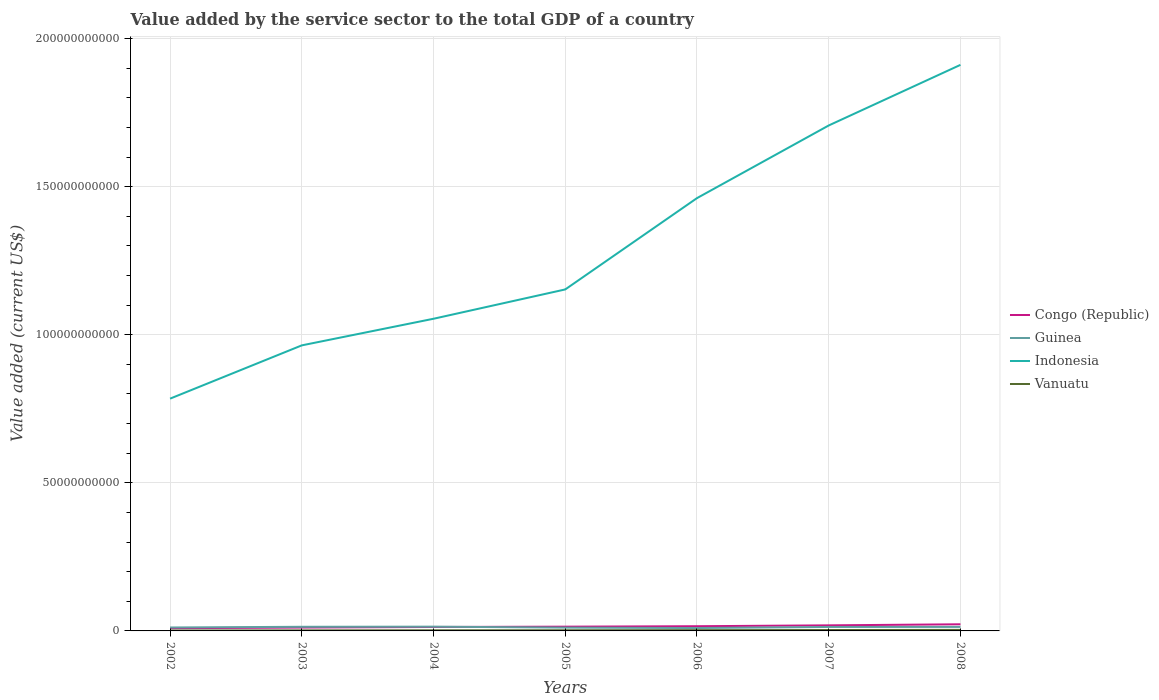Does the line corresponding to Congo (Republic) intersect with the line corresponding to Indonesia?
Provide a succinct answer. No. Is the number of lines equal to the number of legend labels?
Make the answer very short. Yes. Across all years, what is the maximum value added by the service sector to the total GDP in Congo (Republic)?
Keep it short and to the point. 9.19e+08. What is the total value added by the service sector to the total GDP in Vanuatu in the graph?
Give a very brief answer. -1.93e+07. What is the difference between the highest and the second highest value added by the service sector to the total GDP in Guinea?
Provide a short and direct response. 4.61e+08. How many lines are there?
Your response must be concise. 4. How many legend labels are there?
Your response must be concise. 4. How are the legend labels stacked?
Make the answer very short. Vertical. What is the title of the graph?
Keep it short and to the point. Value added by the service sector to the total GDP of a country. What is the label or title of the Y-axis?
Offer a terse response. Value added (current US$). What is the Value added (current US$) in Congo (Republic) in 2002?
Provide a short and direct response. 9.19e+08. What is the Value added (current US$) of Guinea in 2002?
Give a very brief answer. 1.16e+09. What is the Value added (current US$) of Indonesia in 2002?
Offer a terse response. 7.84e+1. What is the Value added (current US$) in Vanuatu in 2002?
Offer a very short reply. 1.45e+08. What is the Value added (current US$) of Congo (Republic) in 2003?
Provide a succinct answer. 1.14e+09. What is the Value added (current US$) in Guinea in 2003?
Make the answer very short. 1.40e+09. What is the Value added (current US$) in Indonesia in 2003?
Your answer should be compact. 9.64e+1. What is the Value added (current US$) of Vanuatu in 2003?
Your response must be concise. 1.81e+08. What is the Value added (current US$) in Congo (Republic) in 2004?
Keep it short and to the point. 1.33e+09. What is the Value added (current US$) in Guinea in 2004?
Ensure brevity in your answer.  1.44e+09. What is the Value added (current US$) in Indonesia in 2004?
Ensure brevity in your answer.  1.05e+11. What is the Value added (current US$) in Vanuatu in 2004?
Ensure brevity in your answer.  2.09e+08. What is the Value added (current US$) of Congo (Republic) in 2005?
Keep it short and to the point. 1.43e+09. What is the Value added (current US$) in Guinea in 2005?
Give a very brief answer. 1.11e+09. What is the Value added (current US$) of Indonesia in 2005?
Offer a very short reply. 1.15e+11. What is the Value added (current US$) in Vanuatu in 2005?
Offer a terse response. 2.29e+08. What is the Value added (current US$) of Congo (Republic) in 2006?
Keep it short and to the point. 1.59e+09. What is the Value added (current US$) of Guinea in 2006?
Offer a very short reply. 9.78e+08. What is the Value added (current US$) in Indonesia in 2006?
Your response must be concise. 1.46e+11. What is the Value added (current US$) in Vanuatu in 2006?
Give a very brief answer. 2.60e+08. What is the Value added (current US$) of Congo (Republic) in 2007?
Give a very brief answer. 1.88e+09. What is the Value added (current US$) of Guinea in 2007?
Make the answer very short. 1.34e+09. What is the Value added (current US$) in Indonesia in 2007?
Ensure brevity in your answer.  1.71e+11. What is the Value added (current US$) of Vanuatu in 2007?
Ensure brevity in your answer.  3.08e+08. What is the Value added (current US$) of Congo (Republic) in 2008?
Offer a terse response. 2.24e+09. What is the Value added (current US$) of Guinea in 2008?
Your answer should be very brief. 1.35e+09. What is the Value added (current US$) in Indonesia in 2008?
Offer a very short reply. 1.91e+11. What is the Value added (current US$) in Vanuatu in 2008?
Ensure brevity in your answer.  3.49e+08. Across all years, what is the maximum Value added (current US$) in Congo (Republic)?
Offer a terse response. 2.24e+09. Across all years, what is the maximum Value added (current US$) in Guinea?
Provide a succinct answer. 1.44e+09. Across all years, what is the maximum Value added (current US$) in Indonesia?
Give a very brief answer. 1.91e+11. Across all years, what is the maximum Value added (current US$) in Vanuatu?
Make the answer very short. 3.49e+08. Across all years, what is the minimum Value added (current US$) of Congo (Republic)?
Give a very brief answer. 9.19e+08. Across all years, what is the minimum Value added (current US$) of Guinea?
Offer a very short reply. 9.78e+08. Across all years, what is the minimum Value added (current US$) of Indonesia?
Offer a terse response. 7.84e+1. Across all years, what is the minimum Value added (current US$) in Vanuatu?
Provide a succinct answer. 1.45e+08. What is the total Value added (current US$) of Congo (Republic) in the graph?
Offer a very short reply. 1.05e+1. What is the total Value added (current US$) in Guinea in the graph?
Make the answer very short. 8.78e+09. What is the total Value added (current US$) in Indonesia in the graph?
Provide a short and direct response. 9.03e+11. What is the total Value added (current US$) of Vanuatu in the graph?
Provide a succinct answer. 1.68e+09. What is the difference between the Value added (current US$) of Congo (Republic) in 2002 and that in 2003?
Your response must be concise. -2.19e+08. What is the difference between the Value added (current US$) of Guinea in 2002 and that in 2003?
Keep it short and to the point. -2.35e+08. What is the difference between the Value added (current US$) of Indonesia in 2002 and that in 2003?
Provide a short and direct response. -1.80e+1. What is the difference between the Value added (current US$) in Vanuatu in 2002 and that in 2003?
Your response must be concise. -3.66e+07. What is the difference between the Value added (current US$) in Congo (Republic) in 2002 and that in 2004?
Provide a succinct answer. -4.12e+08. What is the difference between the Value added (current US$) in Guinea in 2002 and that in 2004?
Keep it short and to the point. -2.76e+08. What is the difference between the Value added (current US$) in Indonesia in 2002 and that in 2004?
Provide a short and direct response. -2.70e+1. What is the difference between the Value added (current US$) in Vanuatu in 2002 and that in 2004?
Give a very brief answer. -6.46e+07. What is the difference between the Value added (current US$) in Congo (Republic) in 2002 and that in 2005?
Offer a terse response. -5.16e+08. What is the difference between the Value added (current US$) of Guinea in 2002 and that in 2005?
Provide a succinct answer. 4.98e+07. What is the difference between the Value added (current US$) in Indonesia in 2002 and that in 2005?
Ensure brevity in your answer.  -3.69e+1. What is the difference between the Value added (current US$) of Vanuatu in 2002 and that in 2005?
Provide a succinct answer. -8.39e+07. What is the difference between the Value added (current US$) in Congo (Republic) in 2002 and that in 2006?
Provide a short and direct response. -6.69e+08. What is the difference between the Value added (current US$) of Guinea in 2002 and that in 2006?
Offer a very short reply. 1.84e+08. What is the difference between the Value added (current US$) of Indonesia in 2002 and that in 2006?
Offer a very short reply. -6.77e+1. What is the difference between the Value added (current US$) of Vanuatu in 2002 and that in 2006?
Provide a short and direct response. -1.15e+08. What is the difference between the Value added (current US$) of Congo (Republic) in 2002 and that in 2007?
Ensure brevity in your answer.  -9.64e+08. What is the difference between the Value added (current US$) of Guinea in 2002 and that in 2007?
Your response must be concise. -1.77e+08. What is the difference between the Value added (current US$) of Indonesia in 2002 and that in 2007?
Keep it short and to the point. -9.22e+1. What is the difference between the Value added (current US$) of Vanuatu in 2002 and that in 2007?
Provide a succinct answer. -1.63e+08. What is the difference between the Value added (current US$) in Congo (Republic) in 2002 and that in 2008?
Keep it short and to the point. -1.32e+09. What is the difference between the Value added (current US$) in Guinea in 2002 and that in 2008?
Give a very brief answer. -1.88e+08. What is the difference between the Value added (current US$) of Indonesia in 2002 and that in 2008?
Your answer should be compact. -1.13e+11. What is the difference between the Value added (current US$) in Vanuatu in 2002 and that in 2008?
Your answer should be very brief. -2.04e+08. What is the difference between the Value added (current US$) in Congo (Republic) in 2003 and that in 2004?
Ensure brevity in your answer.  -1.93e+08. What is the difference between the Value added (current US$) in Guinea in 2003 and that in 2004?
Make the answer very short. -4.10e+07. What is the difference between the Value added (current US$) of Indonesia in 2003 and that in 2004?
Provide a succinct answer. -8.99e+09. What is the difference between the Value added (current US$) of Vanuatu in 2003 and that in 2004?
Give a very brief answer. -2.80e+07. What is the difference between the Value added (current US$) in Congo (Republic) in 2003 and that in 2005?
Ensure brevity in your answer.  -2.97e+08. What is the difference between the Value added (current US$) of Guinea in 2003 and that in 2005?
Offer a very short reply. 2.85e+08. What is the difference between the Value added (current US$) of Indonesia in 2003 and that in 2005?
Your response must be concise. -1.89e+1. What is the difference between the Value added (current US$) in Vanuatu in 2003 and that in 2005?
Ensure brevity in your answer.  -4.73e+07. What is the difference between the Value added (current US$) of Congo (Republic) in 2003 and that in 2006?
Provide a succinct answer. -4.50e+08. What is the difference between the Value added (current US$) of Guinea in 2003 and that in 2006?
Offer a terse response. 4.20e+08. What is the difference between the Value added (current US$) of Indonesia in 2003 and that in 2006?
Your answer should be very brief. -4.97e+1. What is the difference between the Value added (current US$) in Vanuatu in 2003 and that in 2006?
Your response must be concise. -7.84e+07. What is the difference between the Value added (current US$) in Congo (Republic) in 2003 and that in 2007?
Keep it short and to the point. -7.45e+08. What is the difference between the Value added (current US$) in Guinea in 2003 and that in 2007?
Provide a short and direct response. 5.83e+07. What is the difference between the Value added (current US$) of Indonesia in 2003 and that in 2007?
Provide a short and direct response. -7.42e+1. What is the difference between the Value added (current US$) in Vanuatu in 2003 and that in 2007?
Your answer should be very brief. -1.26e+08. What is the difference between the Value added (current US$) in Congo (Republic) in 2003 and that in 2008?
Offer a very short reply. -1.10e+09. What is the difference between the Value added (current US$) of Guinea in 2003 and that in 2008?
Offer a terse response. 4.74e+07. What is the difference between the Value added (current US$) in Indonesia in 2003 and that in 2008?
Ensure brevity in your answer.  -9.47e+1. What is the difference between the Value added (current US$) in Vanuatu in 2003 and that in 2008?
Give a very brief answer. -1.67e+08. What is the difference between the Value added (current US$) in Congo (Republic) in 2004 and that in 2005?
Offer a very short reply. -1.04e+08. What is the difference between the Value added (current US$) of Guinea in 2004 and that in 2005?
Offer a terse response. 3.26e+08. What is the difference between the Value added (current US$) in Indonesia in 2004 and that in 2005?
Provide a short and direct response. -9.90e+09. What is the difference between the Value added (current US$) of Vanuatu in 2004 and that in 2005?
Ensure brevity in your answer.  -1.93e+07. What is the difference between the Value added (current US$) of Congo (Republic) in 2004 and that in 2006?
Make the answer very short. -2.57e+08. What is the difference between the Value added (current US$) of Guinea in 2004 and that in 2006?
Provide a succinct answer. 4.61e+08. What is the difference between the Value added (current US$) of Indonesia in 2004 and that in 2006?
Ensure brevity in your answer.  -4.07e+1. What is the difference between the Value added (current US$) in Vanuatu in 2004 and that in 2006?
Make the answer very short. -5.04e+07. What is the difference between the Value added (current US$) in Congo (Republic) in 2004 and that in 2007?
Make the answer very short. -5.52e+08. What is the difference between the Value added (current US$) in Guinea in 2004 and that in 2007?
Provide a succinct answer. 9.93e+07. What is the difference between the Value added (current US$) in Indonesia in 2004 and that in 2007?
Keep it short and to the point. -6.53e+1. What is the difference between the Value added (current US$) in Vanuatu in 2004 and that in 2007?
Offer a very short reply. -9.82e+07. What is the difference between the Value added (current US$) in Congo (Republic) in 2004 and that in 2008?
Keep it short and to the point. -9.12e+08. What is the difference between the Value added (current US$) of Guinea in 2004 and that in 2008?
Keep it short and to the point. 8.85e+07. What is the difference between the Value added (current US$) of Indonesia in 2004 and that in 2008?
Ensure brevity in your answer.  -8.57e+1. What is the difference between the Value added (current US$) of Vanuatu in 2004 and that in 2008?
Your response must be concise. -1.39e+08. What is the difference between the Value added (current US$) of Congo (Republic) in 2005 and that in 2006?
Give a very brief answer. -1.53e+08. What is the difference between the Value added (current US$) of Guinea in 2005 and that in 2006?
Offer a terse response. 1.35e+08. What is the difference between the Value added (current US$) of Indonesia in 2005 and that in 2006?
Your answer should be compact. -3.08e+1. What is the difference between the Value added (current US$) in Vanuatu in 2005 and that in 2006?
Offer a very short reply. -3.11e+07. What is the difference between the Value added (current US$) of Congo (Republic) in 2005 and that in 2007?
Provide a succinct answer. -4.48e+08. What is the difference between the Value added (current US$) of Guinea in 2005 and that in 2007?
Your response must be concise. -2.27e+08. What is the difference between the Value added (current US$) in Indonesia in 2005 and that in 2007?
Offer a terse response. -5.54e+1. What is the difference between the Value added (current US$) in Vanuatu in 2005 and that in 2007?
Offer a terse response. -7.89e+07. What is the difference between the Value added (current US$) of Congo (Republic) in 2005 and that in 2008?
Provide a succinct answer. -8.07e+08. What is the difference between the Value added (current US$) in Guinea in 2005 and that in 2008?
Provide a succinct answer. -2.38e+08. What is the difference between the Value added (current US$) of Indonesia in 2005 and that in 2008?
Give a very brief answer. -7.58e+1. What is the difference between the Value added (current US$) in Vanuatu in 2005 and that in 2008?
Offer a very short reply. -1.20e+08. What is the difference between the Value added (current US$) in Congo (Republic) in 2006 and that in 2007?
Keep it short and to the point. -2.95e+08. What is the difference between the Value added (current US$) of Guinea in 2006 and that in 2007?
Provide a succinct answer. -3.61e+08. What is the difference between the Value added (current US$) in Indonesia in 2006 and that in 2007?
Your answer should be compact. -2.45e+1. What is the difference between the Value added (current US$) of Vanuatu in 2006 and that in 2007?
Offer a very short reply. -4.78e+07. What is the difference between the Value added (current US$) of Congo (Republic) in 2006 and that in 2008?
Your response must be concise. -6.55e+08. What is the difference between the Value added (current US$) of Guinea in 2006 and that in 2008?
Your response must be concise. -3.72e+08. What is the difference between the Value added (current US$) in Indonesia in 2006 and that in 2008?
Your answer should be compact. -4.50e+1. What is the difference between the Value added (current US$) of Vanuatu in 2006 and that in 2008?
Your answer should be very brief. -8.88e+07. What is the difference between the Value added (current US$) in Congo (Republic) in 2007 and that in 2008?
Your answer should be compact. -3.59e+08. What is the difference between the Value added (current US$) in Guinea in 2007 and that in 2008?
Make the answer very short. -1.09e+07. What is the difference between the Value added (current US$) in Indonesia in 2007 and that in 2008?
Provide a short and direct response. -2.05e+1. What is the difference between the Value added (current US$) in Vanuatu in 2007 and that in 2008?
Your response must be concise. -4.10e+07. What is the difference between the Value added (current US$) of Congo (Republic) in 2002 and the Value added (current US$) of Guinea in 2003?
Give a very brief answer. -4.79e+08. What is the difference between the Value added (current US$) in Congo (Republic) in 2002 and the Value added (current US$) in Indonesia in 2003?
Ensure brevity in your answer.  -9.55e+1. What is the difference between the Value added (current US$) in Congo (Republic) in 2002 and the Value added (current US$) in Vanuatu in 2003?
Make the answer very short. 7.37e+08. What is the difference between the Value added (current US$) in Guinea in 2002 and the Value added (current US$) in Indonesia in 2003?
Offer a terse response. -9.52e+1. What is the difference between the Value added (current US$) in Guinea in 2002 and the Value added (current US$) in Vanuatu in 2003?
Provide a short and direct response. 9.81e+08. What is the difference between the Value added (current US$) in Indonesia in 2002 and the Value added (current US$) in Vanuatu in 2003?
Give a very brief answer. 7.82e+1. What is the difference between the Value added (current US$) in Congo (Republic) in 2002 and the Value added (current US$) in Guinea in 2004?
Offer a terse response. -5.20e+08. What is the difference between the Value added (current US$) of Congo (Republic) in 2002 and the Value added (current US$) of Indonesia in 2004?
Offer a very short reply. -1.04e+11. What is the difference between the Value added (current US$) in Congo (Republic) in 2002 and the Value added (current US$) in Vanuatu in 2004?
Your answer should be compact. 7.09e+08. What is the difference between the Value added (current US$) in Guinea in 2002 and the Value added (current US$) in Indonesia in 2004?
Give a very brief answer. -1.04e+11. What is the difference between the Value added (current US$) of Guinea in 2002 and the Value added (current US$) of Vanuatu in 2004?
Offer a very short reply. 9.53e+08. What is the difference between the Value added (current US$) in Indonesia in 2002 and the Value added (current US$) in Vanuatu in 2004?
Your answer should be compact. 7.82e+1. What is the difference between the Value added (current US$) in Congo (Republic) in 2002 and the Value added (current US$) in Guinea in 2005?
Give a very brief answer. -1.94e+08. What is the difference between the Value added (current US$) in Congo (Republic) in 2002 and the Value added (current US$) in Indonesia in 2005?
Give a very brief answer. -1.14e+11. What is the difference between the Value added (current US$) in Congo (Republic) in 2002 and the Value added (current US$) in Vanuatu in 2005?
Provide a short and direct response. 6.90e+08. What is the difference between the Value added (current US$) in Guinea in 2002 and the Value added (current US$) in Indonesia in 2005?
Make the answer very short. -1.14e+11. What is the difference between the Value added (current US$) of Guinea in 2002 and the Value added (current US$) of Vanuatu in 2005?
Keep it short and to the point. 9.34e+08. What is the difference between the Value added (current US$) in Indonesia in 2002 and the Value added (current US$) in Vanuatu in 2005?
Keep it short and to the point. 7.82e+1. What is the difference between the Value added (current US$) in Congo (Republic) in 2002 and the Value added (current US$) in Guinea in 2006?
Your answer should be compact. -5.96e+07. What is the difference between the Value added (current US$) of Congo (Republic) in 2002 and the Value added (current US$) of Indonesia in 2006?
Your answer should be very brief. -1.45e+11. What is the difference between the Value added (current US$) of Congo (Republic) in 2002 and the Value added (current US$) of Vanuatu in 2006?
Provide a short and direct response. 6.59e+08. What is the difference between the Value added (current US$) of Guinea in 2002 and the Value added (current US$) of Indonesia in 2006?
Provide a short and direct response. -1.45e+11. What is the difference between the Value added (current US$) of Guinea in 2002 and the Value added (current US$) of Vanuatu in 2006?
Offer a terse response. 9.03e+08. What is the difference between the Value added (current US$) in Indonesia in 2002 and the Value added (current US$) in Vanuatu in 2006?
Your answer should be compact. 7.82e+1. What is the difference between the Value added (current US$) in Congo (Republic) in 2002 and the Value added (current US$) in Guinea in 2007?
Make the answer very short. -4.21e+08. What is the difference between the Value added (current US$) in Congo (Republic) in 2002 and the Value added (current US$) in Indonesia in 2007?
Ensure brevity in your answer.  -1.70e+11. What is the difference between the Value added (current US$) in Congo (Republic) in 2002 and the Value added (current US$) in Vanuatu in 2007?
Your answer should be compact. 6.11e+08. What is the difference between the Value added (current US$) of Guinea in 2002 and the Value added (current US$) of Indonesia in 2007?
Make the answer very short. -1.69e+11. What is the difference between the Value added (current US$) in Guinea in 2002 and the Value added (current US$) in Vanuatu in 2007?
Your answer should be very brief. 8.55e+08. What is the difference between the Value added (current US$) of Indonesia in 2002 and the Value added (current US$) of Vanuatu in 2007?
Your answer should be compact. 7.81e+1. What is the difference between the Value added (current US$) of Congo (Republic) in 2002 and the Value added (current US$) of Guinea in 2008?
Your answer should be compact. -4.32e+08. What is the difference between the Value added (current US$) in Congo (Republic) in 2002 and the Value added (current US$) in Indonesia in 2008?
Provide a short and direct response. -1.90e+11. What is the difference between the Value added (current US$) of Congo (Republic) in 2002 and the Value added (current US$) of Vanuatu in 2008?
Give a very brief answer. 5.70e+08. What is the difference between the Value added (current US$) in Guinea in 2002 and the Value added (current US$) in Indonesia in 2008?
Give a very brief answer. -1.90e+11. What is the difference between the Value added (current US$) of Guinea in 2002 and the Value added (current US$) of Vanuatu in 2008?
Offer a very short reply. 8.14e+08. What is the difference between the Value added (current US$) of Indonesia in 2002 and the Value added (current US$) of Vanuatu in 2008?
Provide a short and direct response. 7.81e+1. What is the difference between the Value added (current US$) of Congo (Republic) in 2003 and the Value added (current US$) of Guinea in 2004?
Make the answer very short. -3.01e+08. What is the difference between the Value added (current US$) in Congo (Republic) in 2003 and the Value added (current US$) in Indonesia in 2004?
Your response must be concise. -1.04e+11. What is the difference between the Value added (current US$) in Congo (Republic) in 2003 and the Value added (current US$) in Vanuatu in 2004?
Offer a terse response. 9.29e+08. What is the difference between the Value added (current US$) of Guinea in 2003 and the Value added (current US$) of Indonesia in 2004?
Your answer should be compact. -1.04e+11. What is the difference between the Value added (current US$) in Guinea in 2003 and the Value added (current US$) in Vanuatu in 2004?
Make the answer very short. 1.19e+09. What is the difference between the Value added (current US$) in Indonesia in 2003 and the Value added (current US$) in Vanuatu in 2004?
Your answer should be very brief. 9.62e+1. What is the difference between the Value added (current US$) in Congo (Republic) in 2003 and the Value added (current US$) in Guinea in 2005?
Keep it short and to the point. 2.52e+07. What is the difference between the Value added (current US$) in Congo (Republic) in 2003 and the Value added (current US$) in Indonesia in 2005?
Your answer should be compact. -1.14e+11. What is the difference between the Value added (current US$) of Congo (Republic) in 2003 and the Value added (current US$) of Vanuatu in 2005?
Offer a very short reply. 9.09e+08. What is the difference between the Value added (current US$) in Guinea in 2003 and the Value added (current US$) in Indonesia in 2005?
Your answer should be compact. -1.14e+11. What is the difference between the Value added (current US$) of Guinea in 2003 and the Value added (current US$) of Vanuatu in 2005?
Offer a terse response. 1.17e+09. What is the difference between the Value added (current US$) in Indonesia in 2003 and the Value added (current US$) in Vanuatu in 2005?
Give a very brief answer. 9.62e+1. What is the difference between the Value added (current US$) in Congo (Republic) in 2003 and the Value added (current US$) in Guinea in 2006?
Provide a short and direct response. 1.60e+08. What is the difference between the Value added (current US$) of Congo (Republic) in 2003 and the Value added (current US$) of Indonesia in 2006?
Your answer should be compact. -1.45e+11. What is the difference between the Value added (current US$) of Congo (Republic) in 2003 and the Value added (current US$) of Vanuatu in 2006?
Provide a short and direct response. 8.78e+08. What is the difference between the Value added (current US$) of Guinea in 2003 and the Value added (current US$) of Indonesia in 2006?
Your answer should be very brief. -1.45e+11. What is the difference between the Value added (current US$) in Guinea in 2003 and the Value added (current US$) in Vanuatu in 2006?
Your answer should be compact. 1.14e+09. What is the difference between the Value added (current US$) in Indonesia in 2003 and the Value added (current US$) in Vanuatu in 2006?
Provide a succinct answer. 9.61e+1. What is the difference between the Value added (current US$) of Congo (Republic) in 2003 and the Value added (current US$) of Guinea in 2007?
Your answer should be very brief. -2.02e+08. What is the difference between the Value added (current US$) in Congo (Republic) in 2003 and the Value added (current US$) in Indonesia in 2007?
Your answer should be very brief. -1.70e+11. What is the difference between the Value added (current US$) of Congo (Republic) in 2003 and the Value added (current US$) of Vanuatu in 2007?
Give a very brief answer. 8.30e+08. What is the difference between the Value added (current US$) of Guinea in 2003 and the Value added (current US$) of Indonesia in 2007?
Make the answer very short. -1.69e+11. What is the difference between the Value added (current US$) of Guinea in 2003 and the Value added (current US$) of Vanuatu in 2007?
Offer a very short reply. 1.09e+09. What is the difference between the Value added (current US$) of Indonesia in 2003 and the Value added (current US$) of Vanuatu in 2007?
Give a very brief answer. 9.61e+1. What is the difference between the Value added (current US$) in Congo (Republic) in 2003 and the Value added (current US$) in Guinea in 2008?
Make the answer very short. -2.12e+08. What is the difference between the Value added (current US$) in Congo (Republic) in 2003 and the Value added (current US$) in Indonesia in 2008?
Offer a very short reply. -1.90e+11. What is the difference between the Value added (current US$) in Congo (Republic) in 2003 and the Value added (current US$) in Vanuatu in 2008?
Give a very brief answer. 7.89e+08. What is the difference between the Value added (current US$) in Guinea in 2003 and the Value added (current US$) in Indonesia in 2008?
Make the answer very short. -1.90e+11. What is the difference between the Value added (current US$) of Guinea in 2003 and the Value added (current US$) of Vanuatu in 2008?
Keep it short and to the point. 1.05e+09. What is the difference between the Value added (current US$) in Indonesia in 2003 and the Value added (current US$) in Vanuatu in 2008?
Your answer should be very brief. 9.61e+1. What is the difference between the Value added (current US$) in Congo (Republic) in 2004 and the Value added (current US$) in Guinea in 2005?
Offer a terse response. 2.18e+08. What is the difference between the Value added (current US$) in Congo (Republic) in 2004 and the Value added (current US$) in Indonesia in 2005?
Your response must be concise. -1.14e+11. What is the difference between the Value added (current US$) in Congo (Republic) in 2004 and the Value added (current US$) in Vanuatu in 2005?
Offer a terse response. 1.10e+09. What is the difference between the Value added (current US$) in Guinea in 2004 and the Value added (current US$) in Indonesia in 2005?
Your response must be concise. -1.14e+11. What is the difference between the Value added (current US$) of Guinea in 2004 and the Value added (current US$) of Vanuatu in 2005?
Provide a succinct answer. 1.21e+09. What is the difference between the Value added (current US$) in Indonesia in 2004 and the Value added (current US$) in Vanuatu in 2005?
Your response must be concise. 1.05e+11. What is the difference between the Value added (current US$) of Congo (Republic) in 2004 and the Value added (current US$) of Guinea in 2006?
Offer a very short reply. 3.52e+08. What is the difference between the Value added (current US$) of Congo (Republic) in 2004 and the Value added (current US$) of Indonesia in 2006?
Offer a terse response. -1.45e+11. What is the difference between the Value added (current US$) in Congo (Republic) in 2004 and the Value added (current US$) in Vanuatu in 2006?
Your answer should be very brief. 1.07e+09. What is the difference between the Value added (current US$) of Guinea in 2004 and the Value added (current US$) of Indonesia in 2006?
Ensure brevity in your answer.  -1.45e+11. What is the difference between the Value added (current US$) in Guinea in 2004 and the Value added (current US$) in Vanuatu in 2006?
Provide a succinct answer. 1.18e+09. What is the difference between the Value added (current US$) of Indonesia in 2004 and the Value added (current US$) of Vanuatu in 2006?
Make the answer very short. 1.05e+11. What is the difference between the Value added (current US$) of Congo (Republic) in 2004 and the Value added (current US$) of Guinea in 2007?
Give a very brief answer. -8.82e+06. What is the difference between the Value added (current US$) of Congo (Republic) in 2004 and the Value added (current US$) of Indonesia in 2007?
Your answer should be compact. -1.69e+11. What is the difference between the Value added (current US$) in Congo (Republic) in 2004 and the Value added (current US$) in Vanuatu in 2007?
Ensure brevity in your answer.  1.02e+09. What is the difference between the Value added (current US$) in Guinea in 2004 and the Value added (current US$) in Indonesia in 2007?
Make the answer very short. -1.69e+11. What is the difference between the Value added (current US$) in Guinea in 2004 and the Value added (current US$) in Vanuatu in 2007?
Your response must be concise. 1.13e+09. What is the difference between the Value added (current US$) of Indonesia in 2004 and the Value added (current US$) of Vanuatu in 2007?
Your answer should be very brief. 1.05e+11. What is the difference between the Value added (current US$) in Congo (Republic) in 2004 and the Value added (current US$) in Guinea in 2008?
Make the answer very short. -1.97e+07. What is the difference between the Value added (current US$) of Congo (Republic) in 2004 and the Value added (current US$) of Indonesia in 2008?
Provide a short and direct response. -1.90e+11. What is the difference between the Value added (current US$) of Congo (Republic) in 2004 and the Value added (current US$) of Vanuatu in 2008?
Offer a very short reply. 9.82e+08. What is the difference between the Value added (current US$) of Guinea in 2004 and the Value added (current US$) of Indonesia in 2008?
Provide a short and direct response. -1.90e+11. What is the difference between the Value added (current US$) in Guinea in 2004 and the Value added (current US$) in Vanuatu in 2008?
Make the answer very short. 1.09e+09. What is the difference between the Value added (current US$) of Indonesia in 2004 and the Value added (current US$) of Vanuatu in 2008?
Your response must be concise. 1.05e+11. What is the difference between the Value added (current US$) of Congo (Republic) in 2005 and the Value added (current US$) of Guinea in 2006?
Provide a succinct answer. 4.57e+08. What is the difference between the Value added (current US$) of Congo (Republic) in 2005 and the Value added (current US$) of Indonesia in 2006?
Keep it short and to the point. -1.45e+11. What is the difference between the Value added (current US$) in Congo (Republic) in 2005 and the Value added (current US$) in Vanuatu in 2006?
Keep it short and to the point. 1.18e+09. What is the difference between the Value added (current US$) in Guinea in 2005 and the Value added (current US$) in Indonesia in 2006?
Make the answer very short. -1.45e+11. What is the difference between the Value added (current US$) of Guinea in 2005 and the Value added (current US$) of Vanuatu in 2006?
Your answer should be very brief. 8.53e+08. What is the difference between the Value added (current US$) of Indonesia in 2005 and the Value added (current US$) of Vanuatu in 2006?
Provide a succinct answer. 1.15e+11. What is the difference between the Value added (current US$) in Congo (Republic) in 2005 and the Value added (current US$) in Guinea in 2007?
Keep it short and to the point. 9.54e+07. What is the difference between the Value added (current US$) in Congo (Republic) in 2005 and the Value added (current US$) in Indonesia in 2007?
Your answer should be compact. -1.69e+11. What is the difference between the Value added (current US$) in Congo (Republic) in 2005 and the Value added (current US$) in Vanuatu in 2007?
Give a very brief answer. 1.13e+09. What is the difference between the Value added (current US$) of Guinea in 2005 and the Value added (current US$) of Indonesia in 2007?
Offer a very short reply. -1.70e+11. What is the difference between the Value added (current US$) of Guinea in 2005 and the Value added (current US$) of Vanuatu in 2007?
Keep it short and to the point. 8.05e+08. What is the difference between the Value added (current US$) in Indonesia in 2005 and the Value added (current US$) in Vanuatu in 2007?
Ensure brevity in your answer.  1.15e+11. What is the difference between the Value added (current US$) of Congo (Republic) in 2005 and the Value added (current US$) of Guinea in 2008?
Offer a very short reply. 8.46e+07. What is the difference between the Value added (current US$) of Congo (Republic) in 2005 and the Value added (current US$) of Indonesia in 2008?
Your answer should be very brief. -1.90e+11. What is the difference between the Value added (current US$) of Congo (Republic) in 2005 and the Value added (current US$) of Vanuatu in 2008?
Offer a terse response. 1.09e+09. What is the difference between the Value added (current US$) in Guinea in 2005 and the Value added (current US$) in Indonesia in 2008?
Provide a short and direct response. -1.90e+11. What is the difference between the Value added (current US$) of Guinea in 2005 and the Value added (current US$) of Vanuatu in 2008?
Provide a short and direct response. 7.64e+08. What is the difference between the Value added (current US$) in Indonesia in 2005 and the Value added (current US$) in Vanuatu in 2008?
Offer a terse response. 1.15e+11. What is the difference between the Value added (current US$) in Congo (Republic) in 2006 and the Value added (current US$) in Guinea in 2007?
Offer a very short reply. 2.48e+08. What is the difference between the Value added (current US$) of Congo (Republic) in 2006 and the Value added (current US$) of Indonesia in 2007?
Offer a terse response. -1.69e+11. What is the difference between the Value added (current US$) in Congo (Republic) in 2006 and the Value added (current US$) in Vanuatu in 2007?
Provide a succinct answer. 1.28e+09. What is the difference between the Value added (current US$) in Guinea in 2006 and the Value added (current US$) in Indonesia in 2007?
Make the answer very short. -1.70e+11. What is the difference between the Value added (current US$) of Guinea in 2006 and the Value added (current US$) of Vanuatu in 2007?
Provide a short and direct response. 6.71e+08. What is the difference between the Value added (current US$) in Indonesia in 2006 and the Value added (current US$) in Vanuatu in 2007?
Your response must be concise. 1.46e+11. What is the difference between the Value added (current US$) in Congo (Republic) in 2006 and the Value added (current US$) in Guinea in 2008?
Ensure brevity in your answer.  2.37e+08. What is the difference between the Value added (current US$) of Congo (Republic) in 2006 and the Value added (current US$) of Indonesia in 2008?
Give a very brief answer. -1.90e+11. What is the difference between the Value added (current US$) in Congo (Republic) in 2006 and the Value added (current US$) in Vanuatu in 2008?
Your answer should be very brief. 1.24e+09. What is the difference between the Value added (current US$) in Guinea in 2006 and the Value added (current US$) in Indonesia in 2008?
Offer a terse response. -1.90e+11. What is the difference between the Value added (current US$) in Guinea in 2006 and the Value added (current US$) in Vanuatu in 2008?
Your answer should be compact. 6.30e+08. What is the difference between the Value added (current US$) of Indonesia in 2006 and the Value added (current US$) of Vanuatu in 2008?
Make the answer very short. 1.46e+11. What is the difference between the Value added (current US$) of Congo (Republic) in 2007 and the Value added (current US$) of Guinea in 2008?
Offer a terse response. 5.33e+08. What is the difference between the Value added (current US$) in Congo (Republic) in 2007 and the Value added (current US$) in Indonesia in 2008?
Keep it short and to the point. -1.89e+11. What is the difference between the Value added (current US$) in Congo (Republic) in 2007 and the Value added (current US$) in Vanuatu in 2008?
Ensure brevity in your answer.  1.53e+09. What is the difference between the Value added (current US$) of Guinea in 2007 and the Value added (current US$) of Indonesia in 2008?
Your answer should be compact. -1.90e+11. What is the difference between the Value added (current US$) in Guinea in 2007 and the Value added (current US$) in Vanuatu in 2008?
Your response must be concise. 9.91e+08. What is the difference between the Value added (current US$) of Indonesia in 2007 and the Value added (current US$) of Vanuatu in 2008?
Your answer should be very brief. 1.70e+11. What is the average Value added (current US$) in Congo (Republic) per year?
Make the answer very short. 1.51e+09. What is the average Value added (current US$) of Guinea per year?
Keep it short and to the point. 1.25e+09. What is the average Value added (current US$) of Indonesia per year?
Your answer should be compact. 1.29e+11. What is the average Value added (current US$) in Vanuatu per year?
Offer a terse response. 2.40e+08. In the year 2002, what is the difference between the Value added (current US$) of Congo (Republic) and Value added (current US$) of Guinea?
Your answer should be compact. -2.44e+08. In the year 2002, what is the difference between the Value added (current US$) of Congo (Republic) and Value added (current US$) of Indonesia?
Ensure brevity in your answer.  -7.75e+1. In the year 2002, what is the difference between the Value added (current US$) of Congo (Republic) and Value added (current US$) of Vanuatu?
Offer a very short reply. 7.74e+08. In the year 2002, what is the difference between the Value added (current US$) of Guinea and Value added (current US$) of Indonesia?
Your response must be concise. -7.73e+1. In the year 2002, what is the difference between the Value added (current US$) of Guinea and Value added (current US$) of Vanuatu?
Offer a terse response. 1.02e+09. In the year 2002, what is the difference between the Value added (current US$) in Indonesia and Value added (current US$) in Vanuatu?
Provide a succinct answer. 7.83e+1. In the year 2003, what is the difference between the Value added (current US$) in Congo (Republic) and Value added (current US$) in Guinea?
Make the answer very short. -2.60e+08. In the year 2003, what is the difference between the Value added (current US$) of Congo (Republic) and Value added (current US$) of Indonesia?
Your answer should be very brief. -9.53e+1. In the year 2003, what is the difference between the Value added (current US$) of Congo (Republic) and Value added (current US$) of Vanuatu?
Your answer should be very brief. 9.57e+08. In the year 2003, what is the difference between the Value added (current US$) of Guinea and Value added (current US$) of Indonesia?
Ensure brevity in your answer.  -9.50e+1. In the year 2003, what is the difference between the Value added (current US$) of Guinea and Value added (current US$) of Vanuatu?
Your answer should be very brief. 1.22e+09. In the year 2003, what is the difference between the Value added (current US$) in Indonesia and Value added (current US$) in Vanuatu?
Your answer should be very brief. 9.62e+1. In the year 2004, what is the difference between the Value added (current US$) in Congo (Republic) and Value added (current US$) in Guinea?
Your response must be concise. -1.08e+08. In the year 2004, what is the difference between the Value added (current US$) of Congo (Republic) and Value added (current US$) of Indonesia?
Your answer should be compact. -1.04e+11. In the year 2004, what is the difference between the Value added (current US$) in Congo (Republic) and Value added (current US$) in Vanuatu?
Make the answer very short. 1.12e+09. In the year 2004, what is the difference between the Value added (current US$) of Guinea and Value added (current US$) of Indonesia?
Provide a short and direct response. -1.04e+11. In the year 2004, what is the difference between the Value added (current US$) of Guinea and Value added (current US$) of Vanuatu?
Provide a short and direct response. 1.23e+09. In the year 2004, what is the difference between the Value added (current US$) of Indonesia and Value added (current US$) of Vanuatu?
Make the answer very short. 1.05e+11. In the year 2005, what is the difference between the Value added (current US$) in Congo (Republic) and Value added (current US$) in Guinea?
Your response must be concise. 3.22e+08. In the year 2005, what is the difference between the Value added (current US$) in Congo (Republic) and Value added (current US$) in Indonesia?
Your answer should be very brief. -1.14e+11. In the year 2005, what is the difference between the Value added (current US$) of Congo (Republic) and Value added (current US$) of Vanuatu?
Ensure brevity in your answer.  1.21e+09. In the year 2005, what is the difference between the Value added (current US$) of Guinea and Value added (current US$) of Indonesia?
Your response must be concise. -1.14e+11. In the year 2005, what is the difference between the Value added (current US$) of Guinea and Value added (current US$) of Vanuatu?
Provide a succinct answer. 8.84e+08. In the year 2005, what is the difference between the Value added (current US$) of Indonesia and Value added (current US$) of Vanuatu?
Your answer should be very brief. 1.15e+11. In the year 2006, what is the difference between the Value added (current US$) of Congo (Republic) and Value added (current US$) of Guinea?
Make the answer very short. 6.10e+08. In the year 2006, what is the difference between the Value added (current US$) of Congo (Republic) and Value added (current US$) of Indonesia?
Make the answer very short. -1.45e+11. In the year 2006, what is the difference between the Value added (current US$) of Congo (Republic) and Value added (current US$) of Vanuatu?
Offer a terse response. 1.33e+09. In the year 2006, what is the difference between the Value added (current US$) of Guinea and Value added (current US$) of Indonesia?
Make the answer very short. -1.45e+11. In the year 2006, what is the difference between the Value added (current US$) of Guinea and Value added (current US$) of Vanuatu?
Keep it short and to the point. 7.19e+08. In the year 2006, what is the difference between the Value added (current US$) of Indonesia and Value added (current US$) of Vanuatu?
Offer a terse response. 1.46e+11. In the year 2007, what is the difference between the Value added (current US$) of Congo (Republic) and Value added (current US$) of Guinea?
Provide a short and direct response. 5.44e+08. In the year 2007, what is the difference between the Value added (current US$) of Congo (Republic) and Value added (current US$) of Indonesia?
Provide a succinct answer. -1.69e+11. In the year 2007, what is the difference between the Value added (current US$) in Congo (Republic) and Value added (current US$) in Vanuatu?
Your answer should be very brief. 1.58e+09. In the year 2007, what is the difference between the Value added (current US$) of Guinea and Value added (current US$) of Indonesia?
Provide a short and direct response. -1.69e+11. In the year 2007, what is the difference between the Value added (current US$) in Guinea and Value added (current US$) in Vanuatu?
Ensure brevity in your answer.  1.03e+09. In the year 2007, what is the difference between the Value added (current US$) in Indonesia and Value added (current US$) in Vanuatu?
Provide a short and direct response. 1.70e+11. In the year 2008, what is the difference between the Value added (current US$) in Congo (Republic) and Value added (current US$) in Guinea?
Provide a succinct answer. 8.92e+08. In the year 2008, what is the difference between the Value added (current US$) in Congo (Republic) and Value added (current US$) in Indonesia?
Your answer should be compact. -1.89e+11. In the year 2008, what is the difference between the Value added (current US$) in Congo (Republic) and Value added (current US$) in Vanuatu?
Your answer should be very brief. 1.89e+09. In the year 2008, what is the difference between the Value added (current US$) in Guinea and Value added (current US$) in Indonesia?
Offer a very short reply. -1.90e+11. In the year 2008, what is the difference between the Value added (current US$) in Guinea and Value added (current US$) in Vanuatu?
Give a very brief answer. 1.00e+09. In the year 2008, what is the difference between the Value added (current US$) of Indonesia and Value added (current US$) of Vanuatu?
Keep it short and to the point. 1.91e+11. What is the ratio of the Value added (current US$) of Congo (Republic) in 2002 to that in 2003?
Give a very brief answer. 0.81. What is the ratio of the Value added (current US$) in Guinea in 2002 to that in 2003?
Your answer should be compact. 0.83. What is the ratio of the Value added (current US$) in Indonesia in 2002 to that in 2003?
Ensure brevity in your answer.  0.81. What is the ratio of the Value added (current US$) of Vanuatu in 2002 to that in 2003?
Provide a succinct answer. 0.8. What is the ratio of the Value added (current US$) in Congo (Republic) in 2002 to that in 2004?
Your answer should be very brief. 0.69. What is the ratio of the Value added (current US$) in Guinea in 2002 to that in 2004?
Offer a very short reply. 0.81. What is the ratio of the Value added (current US$) of Indonesia in 2002 to that in 2004?
Give a very brief answer. 0.74. What is the ratio of the Value added (current US$) in Vanuatu in 2002 to that in 2004?
Ensure brevity in your answer.  0.69. What is the ratio of the Value added (current US$) in Congo (Republic) in 2002 to that in 2005?
Make the answer very short. 0.64. What is the ratio of the Value added (current US$) in Guinea in 2002 to that in 2005?
Your answer should be very brief. 1.04. What is the ratio of the Value added (current US$) of Indonesia in 2002 to that in 2005?
Provide a succinct answer. 0.68. What is the ratio of the Value added (current US$) in Vanuatu in 2002 to that in 2005?
Give a very brief answer. 0.63. What is the ratio of the Value added (current US$) of Congo (Republic) in 2002 to that in 2006?
Give a very brief answer. 0.58. What is the ratio of the Value added (current US$) in Guinea in 2002 to that in 2006?
Your answer should be very brief. 1.19. What is the ratio of the Value added (current US$) of Indonesia in 2002 to that in 2006?
Ensure brevity in your answer.  0.54. What is the ratio of the Value added (current US$) in Vanuatu in 2002 to that in 2006?
Your answer should be very brief. 0.56. What is the ratio of the Value added (current US$) of Congo (Republic) in 2002 to that in 2007?
Your response must be concise. 0.49. What is the ratio of the Value added (current US$) of Guinea in 2002 to that in 2007?
Your answer should be compact. 0.87. What is the ratio of the Value added (current US$) in Indonesia in 2002 to that in 2007?
Provide a short and direct response. 0.46. What is the ratio of the Value added (current US$) of Vanuatu in 2002 to that in 2007?
Make the answer very short. 0.47. What is the ratio of the Value added (current US$) in Congo (Republic) in 2002 to that in 2008?
Give a very brief answer. 0.41. What is the ratio of the Value added (current US$) of Guinea in 2002 to that in 2008?
Ensure brevity in your answer.  0.86. What is the ratio of the Value added (current US$) in Indonesia in 2002 to that in 2008?
Provide a short and direct response. 0.41. What is the ratio of the Value added (current US$) in Vanuatu in 2002 to that in 2008?
Provide a short and direct response. 0.42. What is the ratio of the Value added (current US$) of Congo (Republic) in 2003 to that in 2004?
Provide a short and direct response. 0.86. What is the ratio of the Value added (current US$) of Guinea in 2003 to that in 2004?
Your answer should be very brief. 0.97. What is the ratio of the Value added (current US$) in Indonesia in 2003 to that in 2004?
Your answer should be very brief. 0.91. What is the ratio of the Value added (current US$) of Vanuatu in 2003 to that in 2004?
Offer a very short reply. 0.87. What is the ratio of the Value added (current US$) in Congo (Republic) in 2003 to that in 2005?
Give a very brief answer. 0.79. What is the ratio of the Value added (current US$) in Guinea in 2003 to that in 2005?
Make the answer very short. 1.26. What is the ratio of the Value added (current US$) in Indonesia in 2003 to that in 2005?
Make the answer very short. 0.84. What is the ratio of the Value added (current US$) of Vanuatu in 2003 to that in 2005?
Your answer should be very brief. 0.79. What is the ratio of the Value added (current US$) in Congo (Republic) in 2003 to that in 2006?
Give a very brief answer. 0.72. What is the ratio of the Value added (current US$) of Guinea in 2003 to that in 2006?
Make the answer very short. 1.43. What is the ratio of the Value added (current US$) of Indonesia in 2003 to that in 2006?
Offer a very short reply. 0.66. What is the ratio of the Value added (current US$) of Vanuatu in 2003 to that in 2006?
Provide a short and direct response. 0.7. What is the ratio of the Value added (current US$) in Congo (Republic) in 2003 to that in 2007?
Offer a terse response. 0.6. What is the ratio of the Value added (current US$) of Guinea in 2003 to that in 2007?
Provide a short and direct response. 1.04. What is the ratio of the Value added (current US$) in Indonesia in 2003 to that in 2007?
Offer a terse response. 0.56. What is the ratio of the Value added (current US$) of Vanuatu in 2003 to that in 2007?
Ensure brevity in your answer.  0.59. What is the ratio of the Value added (current US$) of Congo (Republic) in 2003 to that in 2008?
Make the answer very short. 0.51. What is the ratio of the Value added (current US$) of Guinea in 2003 to that in 2008?
Offer a very short reply. 1.04. What is the ratio of the Value added (current US$) of Indonesia in 2003 to that in 2008?
Your response must be concise. 0.5. What is the ratio of the Value added (current US$) in Vanuatu in 2003 to that in 2008?
Provide a short and direct response. 0.52. What is the ratio of the Value added (current US$) in Congo (Republic) in 2004 to that in 2005?
Your answer should be very brief. 0.93. What is the ratio of the Value added (current US$) in Guinea in 2004 to that in 2005?
Offer a very short reply. 1.29. What is the ratio of the Value added (current US$) in Indonesia in 2004 to that in 2005?
Make the answer very short. 0.91. What is the ratio of the Value added (current US$) of Vanuatu in 2004 to that in 2005?
Ensure brevity in your answer.  0.92. What is the ratio of the Value added (current US$) in Congo (Republic) in 2004 to that in 2006?
Make the answer very short. 0.84. What is the ratio of the Value added (current US$) in Guinea in 2004 to that in 2006?
Provide a succinct answer. 1.47. What is the ratio of the Value added (current US$) in Indonesia in 2004 to that in 2006?
Offer a very short reply. 0.72. What is the ratio of the Value added (current US$) in Vanuatu in 2004 to that in 2006?
Provide a short and direct response. 0.81. What is the ratio of the Value added (current US$) of Congo (Republic) in 2004 to that in 2007?
Provide a succinct answer. 0.71. What is the ratio of the Value added (current US$) of Guinea in 2004 to that in 2007?
Ensure brevity in your answer.  1.07. What is the ratio of the Value added (current US$) in Indonesia in 2004 to that in 2007?
Offer a terse response. 0.62. What is the ratio of the Value added (current US$) in Vanuatu in 2004 to that in 2007?
Provide a succinct answer. 0.68. What is the ratio of the Value added (current US$) of Congo (Republic) in 2004 to that in 2008?
Ensure brevity in your answer.  0.59. What is the ratio of the Value added (current US$) in Guinea in 2004 to that in 2008?
Offer a very short reply. 1.07. What is the ratio of the Value added (current US$) in Indonesia in 2004 to that in 2008?
Offer a terse response. 0.55. What is the ratio of the Value added (current US$) of Vanuatu in 2004 to that in 2008?
Your response must be concise. 0.6. What is the ratio of the Value added (current US$) of Congo (Republic) in 2005 to that in 2006?
Your answer should be very brief. 0.9. What is the ratio of the Value added (current US$) of Guinea in 2005 to that in 2006?
Offer a terse response. 1.14. What is the ratio of the Value added (current US$) in Indonesia in 2005 to that in 2006?
Your response must be concise. 0.79. What is the ratio of the Value added (current US$) of Vanuatu in 2005 to that in 2006?
Offer a terse response. 0.88. What is the ratio of the Value added (current US$) in Congo (Republic) in 2005 to that in 2007?
Your response must be concise. 0.76. What is the ratio of the Value added (current US$) of Guinea in 2005 to that in 2007?
Make the answer very short. 0.83. What is the ratio of the Value added (current US$) in Indonesia in 2005 to that in 2007?
Give a very brief answer. 0.68. What is the ratio of the Value added (current US$) of Vanuatu in 2005 to that in 2007?
Your answer should be compact. 0.74. What is the ratio of the Value added (current US$) of Congo (Republic) in 2005 to that in 2008?
Ensure brevity in your answer.  0.64. What is the ratio of the Value added (current US$) in Guinea in 2005 to that in 2008?
Keep it short and to the point. 0.82. What is the ratio of the Value added (current US$) of Indonesia in 2005 to that in 2008?
Your answer should be compact. 0.6. What is the ratio of the Value added (current US$) in Vanuatu in 2005 to that in 2008?
Offer a very short reply. 0.66. What is the ratio of the Value added (current US$) in Congo (Republic) in 2006 to that in 2007?
Your answer should be compact. 0.84. What is the ratio of the Value added (current US$) in Guinea in 2006 to that in 2007?
Ensure brevity in your answer.  0.73. What is the ratio of the Value added (current US$) of Indonesia in 2006 to that in 2007?
Your response must be concise. 0.86. What is the ratio of the Value added (current US$) in Vanuatu in 2006 to that in 2007?
Offer a terse response. 0.84. What is the ratio of the Value added (current US$) in Congo (Republic) in 2006 to that in 2008?
Your response must be concise. 0.71. What is the ratio of the Value added (current US$) in Guinea in 2006 to that in 2008?
Your answer should be compact. 0.72. What is the ratio of the Value added (current US$) in Indonesia in 2006 to that in 2008?
Ensure brevity in your answer.  0.76. What is the ratio of the Value added (current US$) of Vanuatu in 2006 to that in 2008?
Provide a succinct answer. 0.75. What is the ratio of the Value added (current US$) in Congo (Republic) in 2007 to that in 2008?
Offer a very short reply. 0.84. What is the ratio of the Value added (current US$) of Guinea in 2007 to that in 2008?
Provide a succinct answer. 0.99. What is the ratio of the Value added (current US$) of Indonesia in 2007 to that in 2008?
Offer a very short reply. 0.89. What is the ratio of the Value added (current US$) in Vanuatu in 2007 to that in 2008?
Provide a succinct answer. 0.88. What is the difference between the highest and the second highest Value added (current US$) in Congo (Republic)?
Provide a succinct answer. 3.59e+08. What is the difference between the highest and the second highest Value added (current US$) of Guinea?
Your answer should be compact. 4.10e+07. What is the difference between the highest and the second highest Value added (current US$) of Indonesia?
Ensure brevity in your answer.  2.05e+1. What is the difference between the highest and the second highest Value added (current US$) in Vanuatu?
Provide a succinct answer. 4.10e+07. What is the difference between the highest and the lowest Value added (current US$) in Congo (Republic)?
Make the answer very short. 1.32e+09. What is the difference between the highest and the lowest Value added (current US$) in Guinea?
Your answer should be compact. 4.61e+08. What is the difference between the highest and the lowest Value added (current US$) of Indonesia?
Provide a short and direct response. 1.13e+11. What is the difference between the highest and the lowest Value added (current US$) of Vanuatu?
Your answer should be compact. 2.04e+08. 